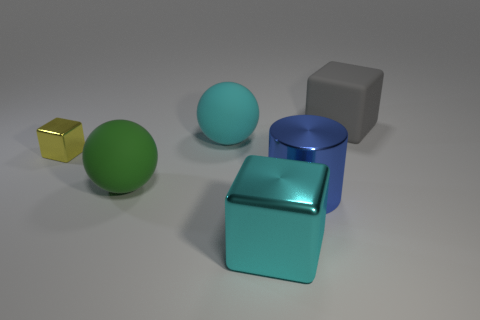Is there anything else that is the same size as the yellow metallic block?
Your response must be concise. No. Is the color of the shiny block that is in front of the yellow metal block the same as the big ball behind the big green sphere?
Offer a terse response. Yes. What number of large blue metal cylinders are behind the large matte sphere left of the rubber ball behind the small thing?
Your answer should be compact. 0. What number of objects are both in front of the gray matte object and right of the yellow thing?
Provide a short and direct response. 4. Are there more large matte balls that are to the left of the large blue metal thing than big brown rubber cylinders?
Your answer should be very brief. Yes. How many gray rubber things have the same size as the blue metal cylinder?
Provide a short and direct response. 1. There is a ball that is the same color as the large shiny cube; what size is it?
Provide a short and direct response. Large. How many small things are red rubber objects or gray things?
Your answer should be compact. 0. How many matte balls are there?
Make the answer very short. 2. Are there the same number of green rubber objects to the left of the small block and big cylinders behind the big blue shiny object?
Ensure brevity in your answer.  Yes. 